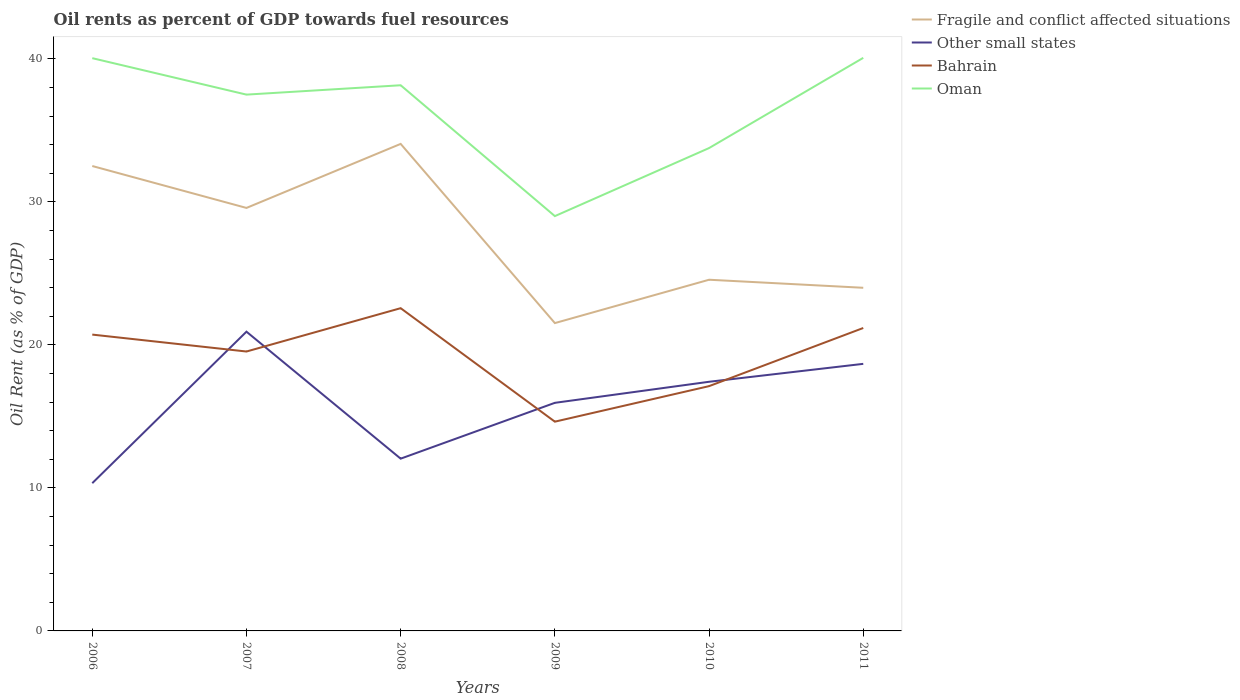Across all years, what is the maximum oil rent in Oman?
Ensure brevity in your answer.  29.01. In which year was the oil rent in Other small states maximum?
Your answer should be compact. 2006. What is the total oil rent in Bahrain in the graph?
Give a very brief answer. 2.42. What is the difference between the highest and the second highest oil rent in Oman?
Provide a short and direct response. 11.07. Is the oil rent in Other small states strictly greater than the oil rent in Bahrain over the years?
Keep it short and to the point. No. How many years are there in the graph?
Ensure brevity in your answer.  6. What is the difference between two consecutive major ticks on the Y-axis?
Provide a short and direct response. 10. Are the values on the major ticks of Y-axis written in scientific E-notation?
Ensure brevity in your answer.  No. Does the graph contain any zero values?
Your answer should be compact. No. Does the graph contain grids?
Your answer should be compact. No. Where does the legend appear in the graph?
Provide a short and direct response. Top right. How many legend labels are there?
Provide a short and direct response. 4. How are the legend labels stacked?
Keep it short and to the point. Vertical. What is the title of the graph?
Offer a terse response. Oil rents as percent of GDP towards fuel resources. Does "Fiji" appear as one of the legend labels in the graph?
Make the answer very short. No. What is the label or title of the X-axis?
Your answer should be compact. Years. What is the label or title of the Y-axis?
Give a very brief answer. Oil Rent (as % of GDP). What is the Oil Rent (as % of GDP) of Fragile and conflict affected situations in 2006?
Ensure brevity in your answer.  32.51. What is the Oil Rent (as % of GDP) in Other small states in 2006?
Provide a short and direct response. 10.33. What is the Oil Rent (as % of GDP) of Bahrain in 2006?
Offer a very short reply. 20.72. What is the Oil Rent (as % of GDP) in Oman in 2006?
Your response must be concise. 40.06. What is the Oil Rent (as % of GDP) of Fragile and conflict affected situations in 2007?
Make the answer very short. 29.58. What is the Oil Rent (as % of GDP) of Other small states in 2007?
Give a very brief answer. 20.93. What is the Oil Rent (as % of GDP) of Bahrain in 2007?
Offer a terse response. 19.54. What is the Oil Rent (as % of GDP) of Oman in 2007?
Your answer should be very brief. 37.51. What is the Oil Rent (as % of GDP) in Fragile and conflict affected situations in 2008?
Your answer should be compact. 34.06. What is the Oil Rent (as % of GDP) of Other small states in 2008?
Offer a terse response. 12.05. What is the Oil Rent (as % of GDP) of Bahrain in 2008?
Offer a very short reply. 22.57. What is the Oil Rent (as % of GDP) of Oman in 2008?
Offer a very short reply. 38.16. What is the Oil Rent (as % of GDP) of Fragile and conflict affected situations in 2009?
Offer a very short reply. 21.53. What is the Oil Rent (as % of GDP) in Other small states in 2009?
Your answer should be compact. 15.95. What is the Oil Rent (as % of GDP) of Bahrain in 2009?
Keep it short and to the point. 14.63. What is the Oil Rent (as % of GDP) of Oman in 2009?
Provide a succinct answer. 29.01. What is the Oil Rent (as % of GDP) in Fragile and conflict affected situations in 2010?
Give a very brief answer. 24.56. What is the Oil Rent (as % of GDP) in Other small states in 2010?
Your answer should be very brief. 17.42. What is the Oil Rent (as % of GDP) of Bahrain in 2010?
Provide a succinct answer. 17.12. What is the Oil Rent (as % of GDP) in Oman in 2010?
Ensure brevity in your answer.  33.77. What is the Oil Rent (as % of GDP) of Fragile and conflict affected situations in 2011?
Make the answer very short. 24. What is the Oil Rent (as % of GDP) of Other small states in 2011?
Give a very brief answer. 18.68. What is the Oil Rent (as % of GDP) in Bahrain in 2011?
Your answer should be compact. 21.18. What is the Oil Rent (as % of GDP) of Oman in 2011?
Your answer should be compact. 40.08. Across all years, what is the maximum Oil Rent (as % of GDP) of Fragile and conflict affected situations?
Your answer should be very brief. 34.06. Across all years, what is the maximum Oil Rent (as % of GDP) in Other small states?
Ensure brevity in your answer.  20.93. Across all years, what is the maximum Oil Rent (as % of GDP) of Bahrain?
Your answer should be very brief. 22.57. Across all years, what is the maximum Oil Rent (as % of GDP) in Oman?
Your answer should be compact. 40.08. Across all years, what is the minimum Oil Rent (as % of GDP) in Fragile and conflict affected situations?
Offer a terse response. 21.53. Across all years, what is the minimum Oil Rent (as % of GDP) of Other small states?
Offer a very short reply. 10.33. Across all years, what is the minimum Oil Rent (as % of GDP) of Bahrain?
Offer a very short reply. 14.63. Across all years, what is the minimum Oil Rent (as % of GDP) of Oman?
Keep it short and to the point. 29.01. What is the total Oil Rent (as % of GDP) of Fragile and conflict affected situations in the graph?
Ensure brevity in your answer.  166.24. What is the total Oil Rent (as % of GDP) in Other small states in the graph?
Your answer should be compact. 95.36. What is the total Oil Rent (as % of GDP) in Bahrain in the graph?
Offer a very short reply. 115.77. What is the total Oil Rent (as % of GDP) in Oman in the graph?
Give a very brief answer. 218.58. What is the difference between the Oil Rent (as % of GDP) of Fragile and conflict affected situations in 2006 and that in 2007?
Keep it short and to the point. 2.93. What is the difference between the Oil Rent (as % of GDP) of Other small states in 2006 and that in 2007?
Offer a very short reply. -10.6. What is the difference between the Oil Rent (as % of GDP) of Bahrain in 2006 and that in 2007?
Your answer should be compact. 1.18. What is the difference between the Oil Rent (as % of GDP) of Oman in 2006 and that in 2007?
Offer a very short reply. 2.55. What is the difference between the Oil Rent (as % of GDP) of Fragile and conflict affected situations in 2006 and that in 2008?
Your response must be concise. -1.55. What is the difference between the Oil Rent (as % of GDP) of Other small states in 2006 and that in 2008?
Your answer should be compact. -1.72. What is the difference between the Oil Rent (as % of GDP) of Bahrain in 2006 and that in 2008?
Offer a very short reply. -1.85. What is the difference between the Oil Rent (as % of GDP) in Oman in 2006 and that in 2008?
Give a very brief answer. 1.89. What is the difference between the Oil Rent (as % of GDP) of Fragile and conflict affected situations in 2006 and that in 2009?
Offer a very short reply. 10.98. What is the difference between the Oil Rent (as % of GDP) in Other small states in 2006 and that in 2009?
Keep it short and to the point. -5.62. What is the difference between the Oil Rent (as % of GDP) in Bahrain in 2006 and that in 2009?
Provide a short and direct response. 6.09. What is the difference between the Oil Rent (as % of GDP) in Oman in 2006 and that in 2009?
Ensure brevity in your answer.  11.05. What is the difference between the Oil Rent (as % of GDP) of Fragile and conflict affected situations in 2006 and that in 2010?
Give a very brief answer. 7.95. What is the difference between the Oil Rent (as % of GDP) in Other small states in 2006 and that in 2010?
Provide a short and direct response. -7.09. What is the difference between the Oil Rent (as % of GDP) in Bahrain in 2006 and that in 2010?
Provide a short and direct response. 3.6. What is the difference between the Oil Rent (as % of GDP) of Oman in 2006 and that in 2010?
Ensure brevity in your answer.  6.29. What is the difference between the Oil Rent (as % of GDP) of Fragile and conflict affected situations in 2006 and that in 2011?
Ensure brevity in your answer.  8.52. What is the difference between the Oil Rent (as % of GDP) in Other small states in 2006 and that in 2011?
Your answer should be very brief. -8.34. What is the difference between the Oil Rent (as % of GDP) in Bahrain in 2006 and that in 2011?
Keep it short and to the point. -0.46. What is the difference between the Oil Rent (as % of GDP) in Oman in 2006 and that in 2011?
Offer a terse response. -0.02. What is the difference between the Oil Rent (as % of GDP) of Fragile and conflict affected situations in 2007 and that in 2008?
Your answer should be very brief. -4.48. What is the difference between the Oil Rent (as % of GDP) in Other small states in 2007 and that in 2008?
Your response must be concise. 8.88. What is the difference between the Oil Rent (as % of GDP) in Bahrain in 2007 and that in 2008?
Your answer should be compact. -3.03. What is the difference between the Oil Rent (as % of GDP) in Oman in 2007 and that in 2008?
Give a very brief answer. -0.66. What is the difference between the Oil Rent (as % of GDP) of Fragile and conflict affected situations in 2007 and that in 2009?
Provide a short and direct response. 8.05. What is the difference between the Oil Rent (as % of GDP) of Other small states in 2007 and that in 2009?
Offer a very short reply. 4.98. What is the difference between the Oil Rent (as % of GDP) in Bahrain in 2007 and that in 2009?
Provide a short and direct response. 4.91. What is the difference between the Oil Rent (as % of GDP) in Oman in 2007 and that in 2009?
Provide a succinct answer. 8.5. What is the difference between the Oil Rent (as % of GDP) in Fragile and conflict affected situations in 2007 and that in 2010?
Give a very brief answer. 5.02. What is the difference between the Oil Rent (as % of GDP) of Other small states in 2007 and that in 2010?
Provide a short and direct response. 3.5. What is the difference between the Oil Rent (as % of GDP) in Bahrain in 2007 and that in 2010?
Keep it short and to the point. 2.42. What is the difference between the Oil Rent (as % of GDP) of Oman in 2007 and that in 2010?
Your answer should be very brief. 3.74. What is the difference between the Oil Rent (as % of GDP) of Fragile and conflict affected situations in 2007 and that in 2011?
Give a very brief answer. 5.58. What is the difference between the Oil Rent (as % of GDP) of Other small states in 2007 and that in 2011?
Make the answer very short. 2.25. What is the difference between the Oil Rent (as % of GDP) of Bahrain in 2007 and that in 2011?
Offer a terse response. -1.65. What is the difference between the Oil Rent (as % of GDP) of Oman in 2007 and that in 2011?
Offer a terse response. -2.57. What is the difference between the Oil Rent (as % of GDP) in Fragile and conflict affected situations in 2008 and that in 2009?
Offer a very short reply. 12.53. What is the difference between the Oil Rent (as % of GDP) in Other small states in 2008 and that in 2009?
Your response must be concise. -3.9. What is the difference between the Oil Rent (as % of GDP) of Bahrain in 2008 and that in 2009?
Provide a succinct answer. 7.94. What is the difference between the Oil Rent (as % of GDP) of Oman in 2008 and that in 2009?
Ensure brevity in your answer.  9.15. What is the difference between the Oil Rent (as % of GDP) in Fragile and conflict affected situations in 2008 and that in 2010?
Ensure brevity in your answer.  9.5. What is the difference between the Oil Rent (as % of GDP) of Other small states in 2008 and that in 2010?
Give a very brief answer. -5.38. What is the difference between the Oil Rent (as % of GDP) of Bahrain in 2008 and that in 2010?
Keep it short and to the point. 5.45. What is the difference between the Oil Rent (as % of GDP) of Oman in 2008 and that in 2010?
Your answer should be compact. 4.39. What is the difference between the Oil Rent (as % of GDP) in Fragile and conflict affected situations in 2008 and that in 2011?
Your answer should be compact. 10.06. What is the difference between the Oil Rent (as % of GDP) in Other small states in 2008 and that in 2011?
Make the answer very short. -6.63. What is the difference between the Oil Rent (as % of GDP) in Bahrain in 2008 and that in 2011?
Provide a succinct answer. 1.39. What is the difference between the Oil Rent (as % of GDP) of Oman in 2008 and that in 2011?
Ensure brevity in your answer.  -1.92. What is the difference between the Oil Rent (as % of GDP) in Fragile and conflict affected situations in 2009 and that in 2010?
Provide a succinct answer. -3.03. What is the difference between the Oil Rent (as % of GDP) in Other small states in 2009 and that in 2010?
Ensure brevity in your answer.  -1.47. What is the difference between the Oil Rent (as % of GDP) of Bahrain in 2009 and that in 2010?
Make the answer very short. -2.48. What is the difference between the Oil Rent (as % of GDP) of Oman in 2009 and that in 2010?
Your response must be concise. -4.76. What is the difference between the Oil Rent (as % of GDP) in Fragile and conflict affected situations in 2009 and that in 2011?
Give a very brief answer. -2.47. What is the difference between the Oil Rent (as % of GDP) in Other small states in 2009 and that in 2011?
Provide a short and direct response. -2.73. What is the difference between the Oil Rent (as % of GDP) in Bahrain in 2009 and that in 2011?
Offer a terse response. -6.55. What is the difference between the Oil Rent (as % of GDP) of Oman in 2009 and that in 2011?
Make the answer very short. -11.07. What is the difference between the Oil Rent (as % of GDP) of Fragile and conflict affected situations in 2010 and that in 2011?
Offer a terse response. 0.56. What is the difference between the Oil Rent (as % of GDP) of Other small states in 2010 and that in 2011?
Your answer should be compact. -1.25. What is the difference between the Oil Rent (as % of GDP) of Bahrain in 2010 and that in 2011?
Ensure brevity in your answer.  -4.07. What is the difference between the Oil Rent (as % of GDP) in Oman in 2010 and that in 2011?
Make the answer very short. -6.31. What is the difference between the Oil Rent (as % of GDP) of Fragile and conflict affected situations in 2006 and the Oil Rent (as % of GDP) of Other small states in 2007?
Make the answer very short. 11.59. What is the difference between the Oil Rent (as % of GDP) in Fragile and conflict affected situations in 2006 and the Oil Rent (as % of GDP) in Bahrain in 2007?
Provide a succinct answer. 12.97. What is the difference between the Oil Rent (as % of GDP) of Fragile and conflict affected situations in 2006 and the Oil Rent (as % of GDP) of Oman in 2007?
Make the answer very short. -4.99. What is the difference between the Oil Rent (as % of GDP) in Other small states in 2006 and the Oil Rent (as % of GDP) in Bahrain in 2007?
Offer a very short reply. -9.21. What is the difference between the Oil Rent (as % of GDP) of Other small states in 2006 and the Oil Rent (as % of GDP) of Oman in 2007?
Ensure brevity in your answer.  -27.17. What is the difference between the Oil Rent (as % of GDP) of Bahrain in 2006 and the Oil Rent (as % of GDP) of Oman in 2007?
Ensure brevity in your answer.  -16.78. What is the difference between the Oil Rent (as % of GDP) in Fragile and conflict affected situations in 2006 and the Oil Rent (as % of GDP) in Other small states in 2008?
Keep it short and to the point. 20.47. What is the difference between the Oil Rent (as % of GDP) of Fragile and conflict affected situations in 2006 and the Oil Rent (as % of GDP) of Bahrain in 2008?
Your response must be concise. 9.94. What is the difference between the Oil Rent (as % of GDP) in Fragile and conflict affected situations in 2006 and the Oil Rent (as % of GDP) in Oman in 2008?
Your answer should be very brief. -5.65. What is the difference between the Oil Rent (as % of GDP) of Other small states in 2006 and the Oil Rent (as % of GDP) of Bahrain in 2008?
Give a very brief answer. -12.24. What is the difference between the Oil Rent (as % of GDP) of Other small states in 2006 and the Oil Rent (as % of GDP) of Oman in 2008?
Your answer should be very brief. -27.83. What is the difference between the Oil Rent (as % of GDP) of Bahrain in 2006 and the Oil Rent (as % of GDP) of Oman in 2008?
Your answer should be compact. -17.44. What is the difference between the Oil Rent (as % of GDP) of Fragile and conflict affected situations in 2006 and the Oil Rent (as % of GDP) of Other small states in 2009?
Make the answer very short. 16.56. What is the difference between the Oil Rent (as % of GDP) in Fragile and conflict affected situations in 2006 and the Oil Rent (as % of GDP) in Bahrain in 2009?
Your answer should be very brief. 17.88. What is the difference between the Oil Rent (as % of GDP) of Fragile and conflict affected situations in 2006 and the Oil Rent (as % of GDP) of Oman in 2009?
Your answer should be very brief. 3.5. What is the difference between the Oil Rent (as % of GDP) in Other small states in 2006 and the Oil Rent (as % of GDP) in Bahrain in 2009?
Provide a succinct answer. -4.3. What is the difference between the Oil Rent (as % of GDP) in Other small states in 2006 and the Oil Rent (as % of GDP) in Oman in 2009?
Make the answer very short. -18.68. What is the difference between the Oil Rent (as % of GDP) of Bahrain in 2006 and the Oil Rent (as % of GDP) of Oman in 2009?
Your answer should be compact. -8.29. What is the difference between the Oil Rent (as % of GDP) in Fragile and conflict affected situations in 2006 and the Oil Rent (as % of GDP) in Other small states in 2010?
Offer a terse response. 15.09. What is the difference between the Oil Rent (as % of GDP) in Fragile and conflict affected situations in 2006 and the Oil Rent (as % of GDP) in Bahrain in 2010?
Provide a succinct answer. 15.39. What is the difference between the Oil Rent (as % of GDP) in Fragile and conflict affected situations in 2006 and the Oil Rent (as % of GDP) in Oman in 2010?
Make the answer very short. -1.26. What is the difference between the Oil Rent (as % of GDP) in Other small states in 2006 and the Oil Rent (as % of GDP) in Bahrain in 2010?
Give a very brief answer. -6.79. What is the difference between the Oil Rent (as % of GDP) in Other small states in 2006 and the Oil Rent (as % of GDP) in Oman in 2010?
Your response must be concise. -23.44. What is the difference between the Oil Rent (as % of GDP) of Bahrain in 2006 and the Oil Rent (as % of GDP) of Oman in 2010?
Make the answer very short. -13.04. What is the difference between the Oil Rent (as % of GDP) of Fragile and conflict affected situations in 2006 and the Oil Rent (as % of GDP) of Other small states in 2011?
Provide a short and direct response. 13.84. What is the difference between the Oil Rent (as % of GDP) in Fragile and conflict affected situations in 2006 and the Oil Rent (as % of GDP) in Bahrain in 2011?
Your answer should be very brief. 11.33. What is the difference between the Oil Rent (as % of GDP) in Fragile and conflict affected situations in 2006 and the Oil Rent (as % of GDP) in Oman in 2011?
Give a very brief answer. -7.57. What is the difference between the Oil Rent (as % of GDP) in Other small states in 2006 and the Oil Rent (as % of GDP) in Bahrain in 2011?
Your response must be concise. -10.85. What is the difference between the Oil Rent (as % of GDP) in Other small states in 2006 and the Oil Rent (as % of GDP) in Oman in 2011?
Offer a very short reply. -29.75. What is the difference between the Oil Rent (as % of GDP) in Bahrain in 2006 and the Oil Rent (as % of GDP) in Oman in 2011?
Make the answer very short. -19.35. What is the difference between the Oil Rent (as % of GDP) in Fragile and conflict affected situations in 2007 and the Oil Rent (as % of GDP) in Other small states in 2008?
Offer a very short reply. 17.53. What is the difference between the Oil Rent (as % of GDP) of Fragile and conflict affected situations in 2007 and the Oil Rent (as % of GDP) of Bahrain in 2008?
Give a very brief answer. 7.01. What is the difference between the Oil Rent (as % of GDP) of Fragile and conflict affected situations in 2007 and the Oil Rent (as % of GDP) of Oman in 2008?
Your answer should be compact. -8.58. What is the difference between the Oil Rent (as % of GDP) in Other small states in 2007 and the Oil Rent (as % of GDP) in Bahrain in 2008?
Give a very brief answer. -1.64. What is the difference between the Oil Rent (as % of GDP) of Other small states in 2007 and the Oil Rent (as % of GDP) of Oman in 2008?
Your answer should be compact. -17.23. What is the difference between the Oil Rent (as % of GDP) in Bahrain in 2007 and the Oil Rent (as % of GDP) in Oman in 2008?
Your response must be concise. -18.62. What is the difference between the Oil Rent (as % of GDP) in Fragile and conflict affected situations in 2007 and the Oil Rent (as % of GDP) in Other small states in 2009?
Ensure brevity in your answer.  13.63. What is the difference between the Oil Rent (as % of GDP) of Fragile and conflict affected situations in 2007 and the Oil Rent (as % of GDP) of Bahrain in 2009?
Your response must be concise. 14.95. What is the difference between the Oil Rent (as % of GDP) in Fragile and conflict affected situations in 2007 and the Oil Rent (as % of GDP) in Oman in 2009?
Your answer should be compact. 0.57. What is the difference between the Oil Rent (as % of GDP) in Other small states in 2007 and the Oil Rent (as % of GDP) in Bahrain in 2009?
Provide a succinct answer. 6.29. What is the difference between the Oil Rent (as % of GDP) of Other small states in 2007 and the Oil Rent (as % of GDP) of Oman in 2009?
Keep it short and to the point. -8.08. What is the difference between the Oil Rent (as % of GDP) of Bahrain in 2007 and the Oil Rent (as % of GDP) of Oman in 2009?
Provide a short and direct response. -9.47. What is the difference between the Oil Rent (as % of GDP) in Fragile and conflict affected situations in 2007 and the Oil Rent (as % of GDP) in Other small states in 2010?
Ensure brevity in your answer.  12.16. What is the difference between the Oil Rent (as % of GDP) in Fragile and conflict affected situations in 2007 and the Oil Rent (as % of GDP) in Bahrain in 2010?
Give a very brief answer. 12.46. What is the difference between the Oil Rent (as % of GDP) of Fragile and conflict affected situations in 2007 and the Oil Rent (as % of GDP) of Oman in 2010?
Make the answer very short. -4.19. What is the difference between the Oil Rent (as % of GDP) of Other small states in 2007 and the Oil Rent (as % of GDP) of Bahrain in 2010?
Ensure brevity in your answer.  3.81. What is the difference between the Oil Rent (as % of GDP) of Other small states in 2007 and the Oil Rent (as % of GDP) of Oman in 2010?
Your response must be concise. -12.84. What is the difference between the Oil Rent (as % of GDP) of Bahrain in 2007 and the Oil Rent (as % of GDP) of Oman in 2010?
Make the answer very short. -14.23. What is the difference between the Oil Rent (as % of GDP) in Fragile and conflict affected situations in 2007 and the Oil Rent (as % of GDP) in Other small states in 2011?
Make the answer very short. 10.9. What is the difference between the Oil Rent (as % of GDP) of Fragile and conflict affected situations in 2007 and the Oil Rent (as % of GDP) of Bahrain in 2011?
Your answer should be very brief. 8.4. What is the difference between the Oil Rent (as % of GDP) in Fragile and conflict affected situations in 2007 and the Oil Rent (as % of GDP) in Oman in 2011?
Offer a terse response. -10.5. What is the difference between the Oil Rent (as % of GDP) of Other small states in 2007 and the Oil Rent (as % of GDP) of Bahrain in 2011?
Your response must be concise. -0.26. What is the difference between the Oil Rent (as % of GDP) of Other small states in 2007 and the Oil Rent (as % of GDP) of Oman in 2011?
Your answer should be very brief. -19.15. What is the difference between the Oil Rent (as % of GDP) in Bahrain in 2007 and the Oil Rent (as % of GDP) in Oman in 2011?
Keep it short and to the point. -20.54. What is the difference between the Oil Rent (as % of GDP) in Fragile and conflict affected situations in 2008 and the Oil Rent (as % of GDP) in Other small states in 2009?
Make the answer very short. 18.11. What is the difference between the Oil Rent (as % of GDP) of Fragile and conflict affected situations in 2008 and the Oil Rent (as % of GDP) of Bahrain in 2009?
Keep it short and to the point. 19.43. What is the difference between the Oil Rent (as % of GDP) in Fragile and conflict affected situations in 2008 and the Oil Rent (as % of GDP) in Oman in 2009?
Make the answer very short. 5.05. What is the difference between the Oil Rent (as % of GDP) in Other small states in 2008 and the Oil Rent (as % of GDP) in Bahrain in 2009?
Keep it short and to the point. -2.59. What is the difference between the Oil Rent (as % of GDP) in Other small states in 2008 and the Oil Rent (as % of GDP) in Oman in 2009?
Your answer should be compact. -16.96. What is the difference between the Oil Rent (as % of GDP) of Bahrain in 2008 and the Oil Rent (as % of GDP) of Oman in 2009?
Provide a succinct answer. -6.44. What is the difference between the Oil Rent (as % of GDP) in Fragile and conflict affected situations in 2008 and the Oil Rent (as % of GDP) in Other small states in 2010?
Ensure brevity in your answer.  16.64. What is the difference between the Oil Rent (as % of GDP) in Fragile and conflict affected situations in 2008 and the Oil Rent (as % of GDP) in Bahrain in 2010?
Provide a succinct answer. 16.94. What is the difference between the Oil Rent (as % of GDP) in Fragile and conflict affected situations in 2008 and the Oil Rent (as % of GDP) in Oman in 2010?
Provide a succinct answer. 0.29. What is the difference between the Oil Rent (as % of GDP) in Other small states in 2008 and the Oil Rent (as % of GDP) in Bahrain in 2010?
Your answer should be very brief. -5.07. What is the difference between the Oil Rent (as % of GDP) in Other small states in 2008 and the Oil Rent (as % of GDP) in Oman in 2010?
Make the answer very short. -21.72. What is the difference between the Oil Rent (as % of GDP) in Bahrain in 2008 and the Oil Rent (as % of GDP) in Oman in 2010?
Ensure brevity in your answer.  -11.2. What is the difference between the Oil Rent (as % of GDP) of Fragile and conflict affected situations in 2008 and the Oil Rent (as % of GDP) of Other small states in 2011?
Your answer should be very brief. 15.38. What is the difference between the Oil Rent (as % of GDP) of Fragile and conflict affected situations in 2008 and the Oil Rent (as % of GDP) of Bahrain in 2011?
Provide a succinct answer. 12.88. What is the difference between the Oil Rent (as % of GDP) in Fragile and conflict affected situations in 2008 and the Oil Rent (as % of GDP) in Oman in 2011?
Keep it short and to the point. -6.02. What is the difference between the Oil Rent (as % of GDP) in Other small states in 2008 and the Oil Rent (as % of GDP) in Bahrain in 2011?
Your answer should be very brief. -9.14. What is the difference between the Oil Rent (as % of GDP) in Other small states in 2008 and the Oil Rent (as % of GDP) in Oman in 2011?
Provide a short and direct response. -28.03. What is the difference between the Oil Rent (as % of GDP) in Bahrain in 2008 and the Oil Rent (as % of GDP) in Oman in 2011?
Provide a short and direct response. -17.51. What is the difference between the Oil Rent (as % of GDP) of Fragile and conflict affected situations in 2009 and the Oil Rent (as % of GDP) of Other small states in 2010?
Give a very brief answer. 4.1. What is the difference between the Oil Rent (as % of GDP) in Fragile and conflict affected situations in 2009 and the Oil Rent (as % of GDP) in Bahrain in 2010?
Provide a short and direct response. 4.41. What is the difference between the Oil Rent (as % of GDP) in Fragile and conflict affected situations in 2009 and the Oil Rent (as % of GDP) in Oman in 2010?
Ensure brevity in your answer.  -12.24. What is the difference between the Oil Rent (as % of GDP) of Other small states in 2009 and the Oil Rent (as % of GDP) of Bahrain in 2010?
Provide a short and direct response. -1.17. What is the difference between the Oil Rent (as % of GDP) of Other small states in 2009 and the Oil Rent (as % of GDP) of Oman in 2010?
Your response must be concise. -17.82. What is the difference between the Oil Rent (as % of GDP) of Bahrain in 2009 and the Oil Rent (as % of GDP) of Oman in 2010?
Make the answer very short. -19.13. What is the difference between the Oil Rent (as % of GDP) of Fragile and conflict affected situations in 2009 and the Oil Rent (as % of GDP) of Other small states in 2011?
Provide a succinct answer. 2.85. What is the difference between the Oil Rent (as % of GDP) in Fragile and conflict affected situations in 2009 and the Oil Rent (as % of GDP) in Bahrain in 2011?
Offer a very short reply. 0.34. What is the difference between the Oil Rent (as % of GDP) of Fragile and conflict affected situations in 2009 and the Oil Rent (as % of GDP) of Oman in 2011?
Offer a very short reply. -18.55. What is the difference between the Oil Rent (as % of GDP) of Other small states in 2009 and the Oil Rent (as % of GDP) of Bahrain in 2011?
Give a very brief answer. -5.23. What is the difference between the Oil Rent (as % of GDP) of Other small states in 2009 and the Oil Rent (as % of GDP) of Oman in 2011?
Offer a terse response. -24.13. What is the difference between the Oil Rent (as % of GDP) of Bahrain in 2009 and the Oil Rent (as % of GDP) of Oman in 2011?
Your answer should be very brief. -25.44. What is the difference between the Oil Rent (as % of GDP) in Fragile and conflict affected situations in 2010 and the Oil Rent (as % of GDP) in Other small states in 2011?
Keep it short and to the point. 5.88. What is the difference between the Oil Rent (as % of GDP) in Fragile and conflict affected situations in 2010 and the Oil Rent (as % of GDP) in Bahrain in 2011?
Your response must be concise. 3.37. What is the difference between the Oil Rent (as % of GDP) in Fragile and conflict affected situations in 2010 and the Oil Rent (as % of GDP) in Oman in 2011?
Your answer should be compact. -15.52. What is the difference between the Oil Rent (as % of GDP) of Other small states in 2010 and the Oil Rent (as % of GDP) of Bahrain in 2011?
Provide a succinct answer. -3.76. What is the difference between the Oil Rent (as % of GDP) of Other small states in 2010 and the Oil Rent (as % of GDP) of Oman in 2011?
Your answer should be compact. -22.65. What is the difference between the Oil Rent (as % of GDP) in Bahrain in 2010 and the Oil Rent (as % of GDP) in Oman in 2011?
Ensure brevity in your answer.  -22.96. What is the average Oil Rent (as % of GDP) in Fragile and conflict affected situations per year?
Provide a short and direct response. 27.71. What is the average Oil Rent (as % of GDP) of Other small states per year?
Provide a succinct answer. 15.89. What is the average Oil Rent (as % of GDP) in Bahrain per year?
Offer a very short reply. 19.3. What is the average Oil Rent (as % of GDP) of Oman per year?
Give a very brief answer. 36.43. In the year 2006, what is the difference between the Oil Rent (as % of GDP) of Fragile and conflict affected situations and Oil Rent (as % of GDP) of Other small states?
Make the answer very short. 22.18. In the year 2006, what is the difference between the Oil Rent (as % of GDP) of Fragile and conflict affected situations and Oil Rent (as % of GDP) of Bahrain?
Your answer should be compact. 11.79. In the year 2006, what is the difference between the Oil Rent (as % of GDP) in Fragile and conflict affected situations and Oil Rent (as % of GDP) in Oman?
Ensure brevity in your answer.  -7.54. In the year 2006, what is the difference between the Oil Rent (as % of GDP) in Other small states and Oil Rent (as % of GDP) in Bahrain?
Offer a terse response. -10.39. In the year 2006, what is the difference between the Oil Rent (as % of GDP) in Other small states and Oil Rent (as % of GDP) in Oman?
Ensure brevity in your answer.  -29.72. In the year 2006, what is the difference between the Oil Rent (as % of GDP) of Bahrain and Oil Rent (as % of GDP) of Oman?
Your response must be concise. -19.33. In the year 2007, what is the difference between the Oil Rent (as % of GDP) of Fragile and conflict affected situations and Oil Rent (as % of GDP) of Other small states?
Ensure brevity in your answer.  8.65. In the year 2007, what is the difference between the Oil Rent (as % of GDP) of Fragile and conflict affected situations and Oil Rent (as % of GDP) of Bahrain?
Offer a terse response. 10.04. In the year 2007, what is the difference between the Oil Rent (as % of GDP) of Fragile and conflict affected situations and Oil Rent (as % of GDP) of Oman?
Provide a succinct answer. -7.92. In the year 2007, what is the difference between the Oil Rent (as % of GDP) in Other small states and Oil Rent (as % of GDP) in Bahrain?
Give a very brief answer. 1.39. In the year 2007, what is the difference between the Oil Rent (as % of GDP) of Other small states and Oil Rent (as % of GDP) of Oman?
Keep it short and to the point. -16.58. In the year 2007, what is the difference between the Oil Rent (as % of GDP) of Bahrain and Oil Rent (as % of GDP) of Oman?
Provide a succinct answer. -17.97. In the year 2008, what is the difference between the Oil Rent (as % of GDP) in Fragile and conflict affected situations and Oil Rent (as % of GDP) in Other small states?
Your answer should be compact. 22.01. In the year 2008, what is the difference between the Oil Rent (as % of GDP) of Fragile and conflict affected situations and Oil Rent (as % of GDP) of Bahrain?
Your answer should be compact. 11.49. In the year 2008, what is the difference between the Oil Rent (as % of GDP) of Fragile and conflict affected situations and Oil Rent (as % of GDP) of Oman?
Your response must be concise. -4.1. In the year 2008, what is the difference between the Oil Rent (as % of GDP) in Other small states and Oil Rent (as % of GDP) in Bahrain?
Ensure brevity in your answer.  -10.52. In the year 2008, what is the difference between the Oil Rent (as % of GDP) of Other small states and Oil Rent (as % of GDP) of Oman?
Your response must be concise. -26.11. In the year 2008, what is the difference between the Oil Rent (as % of GDP) in Bahrain and Oil Rent (as % of GDP) in Oman?
Offer a terse response. -15.59. In the year 2009, what is the difference between the Oil Rent (as % of GDP) in Fragile and conflict affected situations and Oil Rent (as % of GDP) in Other small states?
Provide a short and direct response. 5.58. In the year 2009, what is the difference between the Oil Rent (as % of GDP) of Fragile and conflict affected situations and Oil Rent (as % of GDP) of Bahrain?
Provide a short and direct response. 6.89. In the year 2009, what is the difference between the Oil Rent (as % of GDP) in Fragile and conflict affected situations and Oil Rent (as % of GDP) in Oman?
Provide a short and direct response. -7.48. In the year 2009, what is the difference between the Oil Rent (as % of GDP) of Other small states and Oil Rent (as % of GDP) of Bahrain?
Your response must be concise. 1.32. In the year 2009, what is the difference between the Oil Rent (as % of GDP) in Other small states and Oil Rent (as % of GDP) in Oman?
Give a very brief answer. -13.06. In the year 2009, what is the difference between the Oil Rent (as % of GDP) of Bahrain and Oil Rent (as % of GDP) of Oman?
Your answer should be compact. -14.37. In the year 2010, what is the difference between the Oil Rent (as % of GDP) in Fragile and conflict affected situations and Oil Rent (as % of GDP) in Other small states?
Your answer should be compact. 7.14. In the year 2010, what is the difference between the Oil Rent (as % of GDP) of Fragile and conflict affected situations and Oil Rent (as % of GDP) of Bahrain?
Ensure brevity in your answer.  7.44. In the year 2010, what is the difference between the Oil Rent (as % of GDP) in Fragile and conflict affected situations and Oil Rent (as % of GDP) in Oman?
Offer a very short reply. -9.21. In the year 2010, what is the difference between the Oil Rent (as % of GDP) of Other small states and Oil Rent (as % of GDP) of Bahrain?
Offer a terse response. 0.31. In the year 2010, what is the difference between the Oil Rent (as % of GDP) of Other small states and Oil Rent (as % of GDP) of Oman?
Your answer should be very brief. -16.34. In the year 2010, what is the difference between the Oil Rent (as % of GDP) of Bahrain and Oil Rent (as % of GDP) of Oman?
Make the answer very short. -16.65. In the year 2011, what is the difference between the Oil Rent (as % of GDP) in Fragile and conflict affected situations and Oil Rent (as % of GDP) in Other small states?
Make the answer very short. 5.32. In the year 2011, what is the difference between the Oil Rent (as % of GDP) in Fragile and conflict affected situations and Oil Rent (as % of GDP) in Bahrain?
Provide a short and direct response. 2.81. In the year 2011, what is the difference between the Oil Rent (as % of GDP) of Fragile and conflict affected situations and Oil Rent (as % of GDP) of Oman?
Offer a very short reply. -16.08. In the year 2011, what is the difference between the Oil Rent (as % of GDP) in Other small states and Oil Rent (as % of GDP) in Bahrain?
Keep it short and to the point. -2.51. In the year 2011, what is the difference between the Oil Rent (as % of GDP) in Other small states and Oil Rent (as % of GDP) in Oman?
Your answer should be compact. -21.4. In the year 2011, what is the difference between the Oil Rent (as % of GDP) of Bahrain and Oil Rent (as % of GDP) of Oman?
Your answer should be compact. -18.89. What is the ratio of the Oil Rent (as % of GDP) in Fragile and conflict affected situations in 2006 to that in 2007?
Keep it short and to the point. 1.1. What is the ratio of the Oil Rent (as % of GDP) of Other small states in 2006 to that in 2007?
Provide a succinct answer. 0.49. What is the ratio of the Oil Rent (as % of GDP) of Bahrain in 2006 to that in 2007?
Provide a short and direct response. 1.06. What is the ratio of the Oil Rent (as % of GDP) in Oman in 2006 to that in 2007?
Keep it short and to the point. 1.07. What is the ratio of the Oil Rent (as % of GDP) of Fragile and conflict affected situations in 2006 to that in 2008?
Your answer should be very brief. 0.95. What is the ratio of the Oil Rent (as % of GDP) of Other small states in 2006 to that in 2008?
Provide a succinct answer. 0.86. What is the ratio of the Oil Rent (as % of GDP) of Bahrain in 2006 to that in 2008?
Your answer should be compact. 0.92. What is the ratio of the Oil Rent (as % of GDP) of Oman in 2006 to that in 2008?
Ensure brevity in your answer.  1.05. What is the ratio of the Oil Rent (as % of GDP) in Fragile and conflict affected situations in 2006 to that in 2009?
Make the answer very short. 1.51. What is the ratio of the Oil Rent (as % of GDP) in Other small states in 2006 to that in 2009?
Keep it short and to the point. 0.65. What is the ratio of the Oil Rent (as % of GDP) of Bahrain in 2006 to that in 2009?
Your answer should be very brief. 1.42. What is the ratio of the Oil Rent (as % of GDP) of Oman in 2006 to that in 2009?
Your answer should be very brief. 1.38. What is the ratio of the Oil Rent (as % of GDP) in Fragile and conflict affected situations in 2006 to that in 2010?
Your answer should be very brief. 1.32. What is the ratio of the Oil Rent (as % of GDP) in Other small states in 2006 to that in 2010?
Your answer should be very brief. 0.59. What is the ratio of the Oil Rent (as % of GDP) in Bahrain in 2006 to that in 2010?
Give a very brief answer. 1.21. What is the ratio of the Oil Rent (as % of GDP) in Oman in 2006 to that in 2010?
Provide a succinct answer. 1.19. What is the ratio of the Oil Rent (as % of GDP) of Fragile and conflict affected situations in 2006 to that in 2011?
Offer a terse response. 1.35. What is the ratio of the Oil Rent (as % of GDP) in Other small states in 2006 to that in 2011?
Your response must be concise. 0.55. What is the ratio of the Oil Rent (as % of GDP) of Bahrain in 2006 to that in 2011?
Your response must be concise. 0.98. What is the ratio of the Oil Rent (as % of GDP) in Fragile and conflict affected situations in 2007 to that in 2008?
Your answer should be compact. 0.87. What is the ratio of the Oil Rent (as % of GDP) in Other small states in 2007 to that in 2008?
Your answer should be very brief. 1.74. What is the ratio of the Oil Rent (as % of GDP) in Bahrain in 2007 to that in 2008?
Make the answer very short. 0.87. What is the ratio of the Oil Rent (as % of GDP) in Oman in 2007 to that in 2008?
Offer a very short reply. 0.98. What is the ratio of the Oil Rent (as % of GDP) of Fragile and conflict affected situations in 2007 to that in 2009?
Offer a very short reply. 1.37. What is the ratio of the Oil Rent (as % of GDP) in Other small states in 2007 to that in 2009?
Your answer should be compact. 1.31. What is the ratio of the Oil Rent (as % of GDP) of Bahrain in 2007 to that in 2009?
Make the answer very short. 1.34. What is the ratio of the Oil Rent (as % of GDP) of Oman in 2007 to that in 2009?
Your answer should be very brief. 1.29. What is the ratio of the Oil Rent (as % of GDP) of Fragile and conflict affected situations in 2007 to that in 2010?
Provide a succinct answer. 1.2. What is the ratio of the Oil Rent (as % of GDP) in Other small states in 2007 to that in 2010?
Your response must be concise. 1.2. What is the ratio of the Oil Rent (as % of GDP) of Bahrain in 2007 to that in 2010?
Provide a short and direct response. 1.14. What is the ratio of the Oil Rent (as % of GDP) of Oman in 2007 to that in 2010?
Provide a succinct answer. 1.11. What is the ratio of the Oil Rent (as % of GDP) in Fragile and conflict affected situations in 2007 to that in 2011?
Your response must be concise. 1.23. What is the ratio of the Oil Rent (as % of GDP) of Other small states in 2007 to that in 2011?
Provide a short and direct response. 1.12. What is the ratio of the Oil Rent (as % of GDP) of Bahrain in 2007 to that in 2011?
Offer a terse response. 0.92. What is the ratio of the Oil Rent (as % of GDP) in Oman in 2007 to that in 2011?
Your response must be concise. 0.94. What is the ratio of the Oil Rent (as % of GDP) in Fragile and conflict affected situations in 2008 to that in 2009?
Offer a very short reply. 1.58. What is the ratio of the Oil Rent (as % of GDP) of Other small states in 2008 to that in 2009?
Make the answer very short. 0.76. What is the ratio of the Oil Rent (as % of GDP) in Bahrain in 2008 to that in 2009?
Provide a short and direct response. 1.54. What is the ratio of the Oil Rent (as % of GDP) in Oman in 2008 to that in 2009?
Offer a terse response. 1.32. What is the ratio of the Oil Rent (as % of GDP) of Fragile and conflict affected situations in 2008 to that in 2010?
Provide a succinct answer. 1.39. What is the ratio of the Oil Rent (as % of GDP) of Other small states in 2008 to that in 2010?
Your response must be concise. 0.69. What is the ratio of the Oil Rent (as % of GDP) of Bahrain in 2008 to that in 2010?
Provide a succinct answer. 1.32. What is the ratio of the Oil Rent (as % of GDP) of Oman in 2008 to that in 2010?
Your answer should be compact. 1.13. What is the ratio of the Oil Rent (as % of GDP) of Fragile and conflict affected situations in 2008 to that in 2011?
Make the answer very short. 1.42. What is the ratio of the Oil Rent (as % of GDP) in Other small states in 2008 to that in 2011?
Offer a terse response. 0.65. What is the ratio of the Oil Rent (as % of GDP) in Bahrain in 2008 to that in 2011?
Offer a terse response. 1.07. What is the ratio of the Oil Rent (as % of GDP) in Oman in 2008 to that in 2011?
Ensure brevity in your answer.  0.95. What is the ratio of the Oil Rent (as % of GDP) of Fragile and conflict affected situations in 2009 to that in 2010?
Your answer should be compact. 0.88. What is the ratio of the Oil Rent (as % of GDP) in Other small states in 2009 to that in 2010?
Your answer should be compact. 0.92. What is the ratio of the Oil Rent (as % of GDP) of Bahrain in 2009 to that in 2010?
Offer a terse response. 0.85. What is the ratio of the Oil Rent (as % of GDP) of Oman in 2009 to that in 2010?
Give a very brief answer. 0.86. What is the ratio of the Oil Rent (as % of GDP) of Fragile and conflict affected situations in 2009 to that in 2011?
Ensure brevity in your answer.  0.9. What is the ratio of the Oil Rent (as % of GDP) of Other small states in 2009 to that in 2011?
Your answer should be very brief. 0.85. What is the ratio of the Oil Rent (as % of GDP) in Bahrain in 2009 to that in 2011?
Your answer should be very brief. 0.69. What is the ratio of the Oil Rent (as % of GDP) of Oman in 2009 to that in 2011?
Keep it short and to the point. 0.72. What is the ratio of the Oil Rent (as % of GDP) in Fragile and conflict affected situations in 2010 to that in 2011?
Offer a very short reply. 1.02. What is the ratio of the Oil Rent (as % of GDP) of Other small states in 2010 to that in 2011?
Your answer should be compact. 0.93. What is the ratio of the Oil Rent (as % of GDP) of Bahrain in 2010 to that in 2011?
Provide a succinct answer. 0.81. What is the ratio of the Oil Rent (as % of GDP) in Oman in 2010 to that in 2011?
Your answer should be very brief. 0.84. What is the difference between the highest and the second highest Oil Rent (as % of GDP) of Fragile and conflict affected situations?
Offer a terse response. 1.55. What is the difference between the highest and the second highest Oil Rent (as % of GDP) in Other small states?
Make the answer very short. 2.25. What is the difference between the highest and the second highest Oil Rent (as % of GDP) in Bahrain?
Your response must be concise. 1.39. What is the difference between the highest and the second highest Oil Rent (as % of GDP) in Oman?
Your response must be concise. 0.02. What is the difference between the highest and the lowest Oil Rent (as % of GDP) of Fragile and conflict affected situations?
Offer a very short reply. 12.53. What is the difference between the highest and the lowest Oil Rent (as % of GDP) of Other small states?
Offer a terse response. 10.6. What is the difference between the highest and the lowest Oil Rent (as % of GDP) in Bahrain?
Provide a short and direct response. 7.94. What is the difference between the highest and the lowest Oil Rent (as % of GDP) of Oman?
Provide a succinct answer. 11.07. 